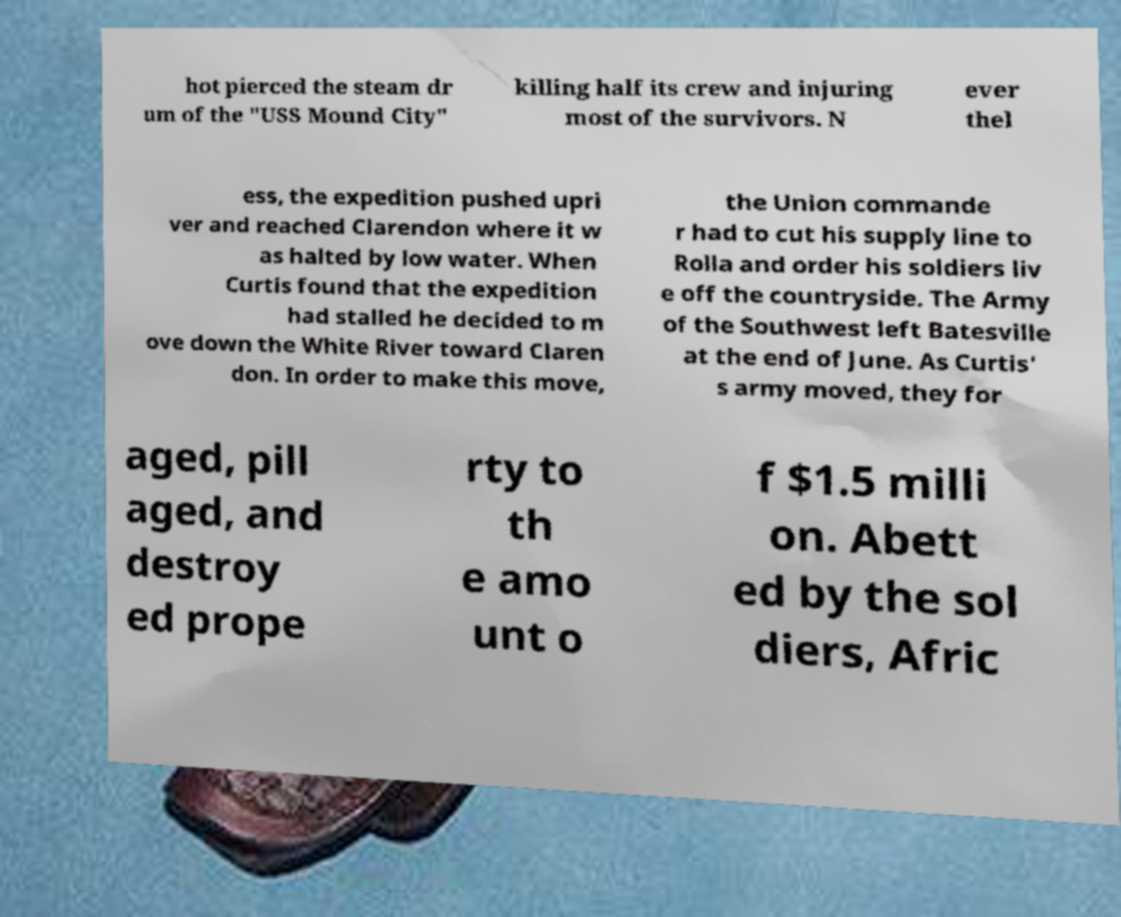There's text embedded in this image that I need extracted. Can you transcribe it verbatim? hot pierced the steam dr um of the "USS Mound City" killing half its crew and injuring most of the survivors. N ever thel ess, the expedition pushed upri ver and reached Clarendon where it w as halted by low water. When Curtis found that the expedition had stalled he decided to m ove down the White River toward Claren don. In order to make this move, the Union commande r had to cut his supply line to Rolla and order his soldiers liv e off the countryside. The Army of the Southwest left Batesville at the end of June. As Curtis' s army moved, they for aged, pill aged, and destroy ed prope rty to th e amo unt o f $1.5 milli on. Abett ed by the sol diers, Afric 